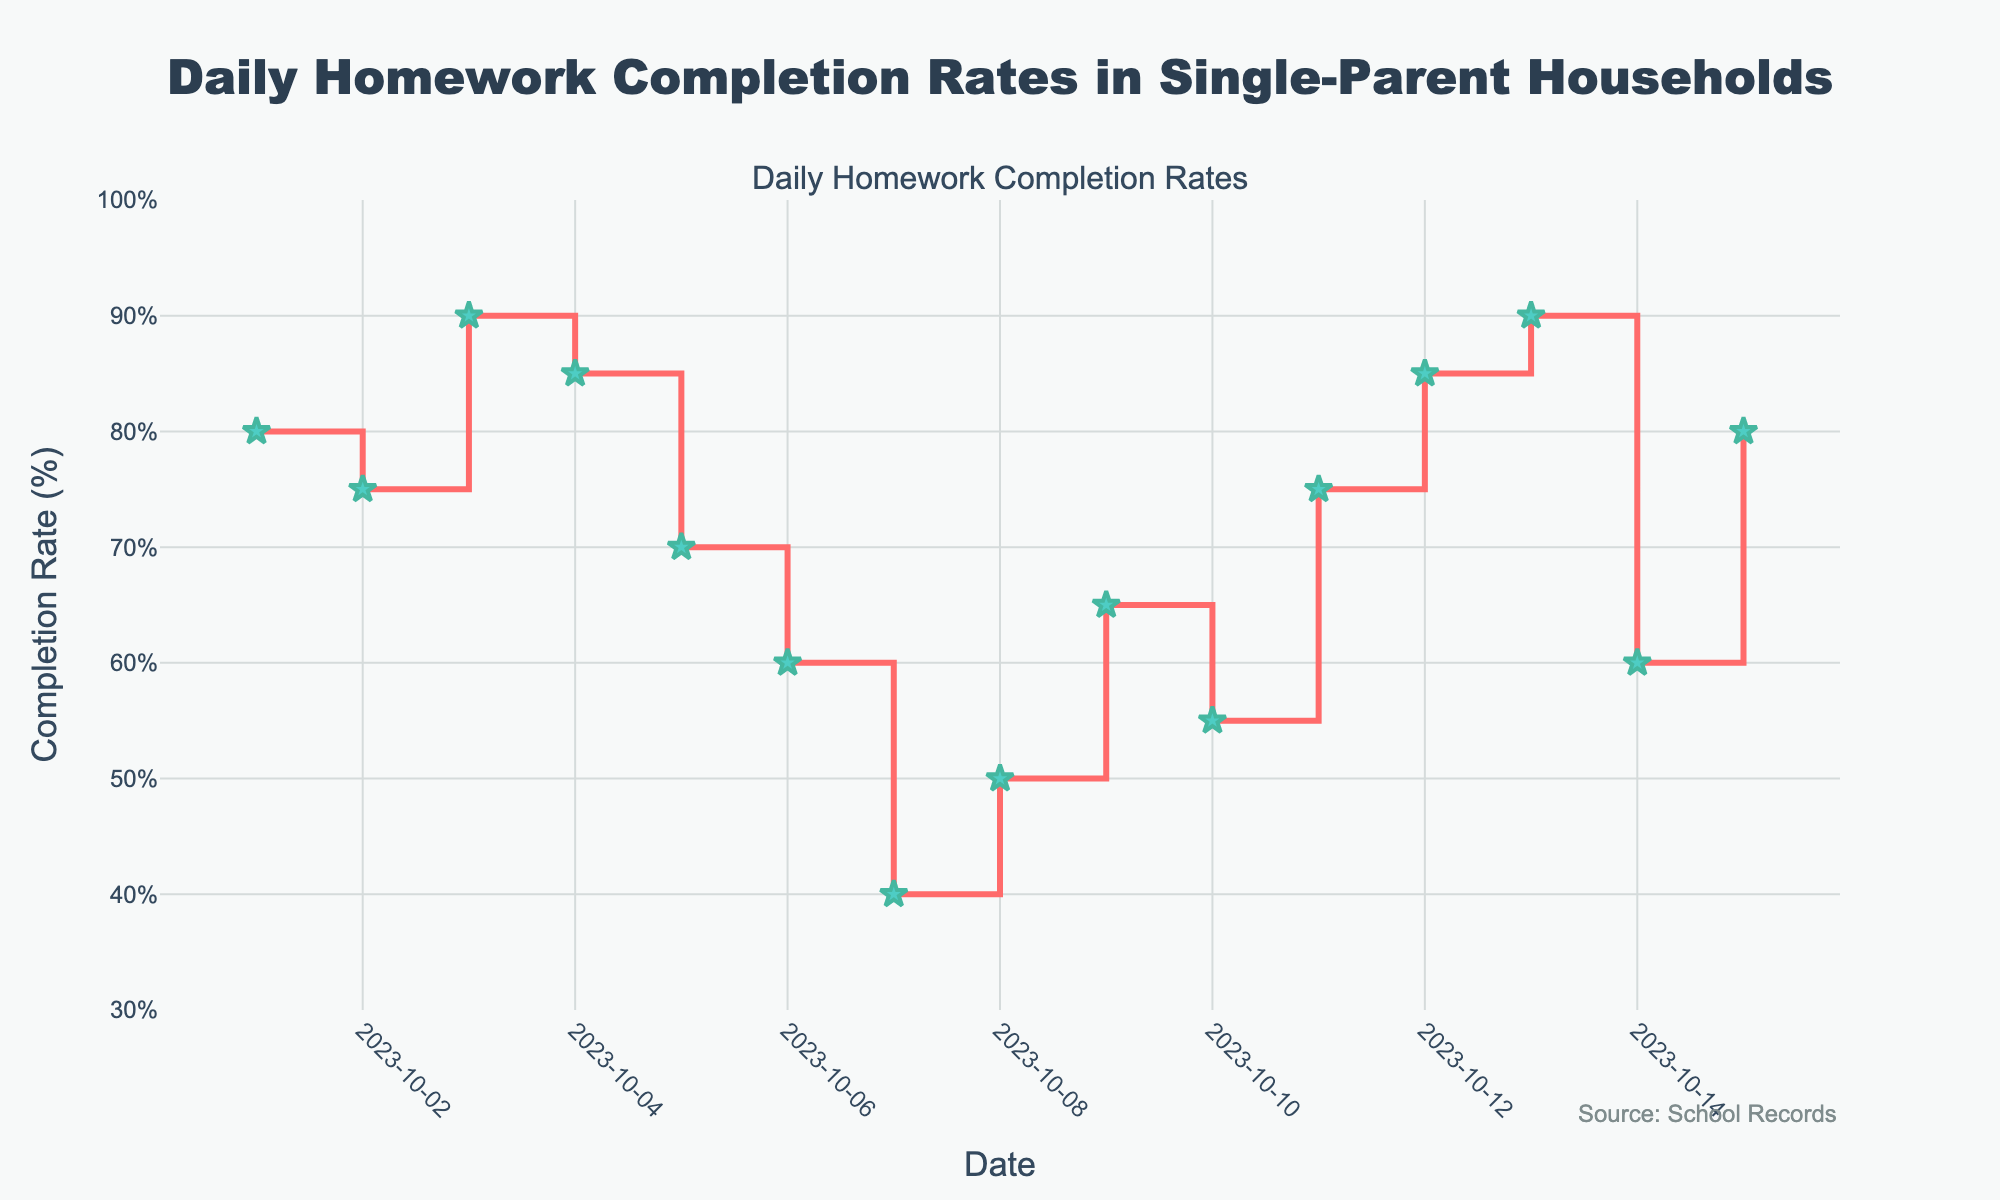What's the title of the figure? The title is prominently displayed at the top of the figure, reading "Daily Homework Completion Rates in Single-Parent Households".
Answer: Daily Homework Completion Rates in Single-Parent Households What are the y-axis units? The y-axis has labels with a '%' symbol, indicating that it measures the completion rate as a percentage.
Answer: Percentage (%) How many days does the data span? The data starts on 2023-10-01 and ends on 2023-10-15, which covers 15 days in total.
Answer: 15 days On which date was the lowest homework completion rate observed? Looking at the stair plot, the lowest point occurs on 2023-10-07 with a completion rate of 40%.
Answer: 2023-10-07 What is the homework completion rate on 2023-10-05? By finding the mark on 2023-10-05, we see the completion rate is 70%.
Answer: 70% How does the completion rate on 2023-10-04 compare to that on 2023-10-11? The completion rate on 2023-10-04 was 85%, while on 2023-10-11 it was 75%, so 2023-10-04 had a higher rate by 10 percentage points.
Answer: 2023-10-04 is 10% higher What is the average homework completion rate over the 15 days? Summing all the percentages and dividing by the number of days: (80+75+90+85+70+60+40+50+65+55+75+85+90+60+80)/15 = 70%.
Answer: 70% How many days had a homework completion rate above 80%? By looking at the data, the days with rates above 80% are 2023-10-03, 2023-10-04, 2023-10-12, and 2023-10-13, which counts to 4 days.
Answer: 4 days What range does the y-axis cover? The y-axis starts at 30% and ends at 100%.
Answer: 30% to 100% How did the homework completion rate change from 2023-10-06 to 2023-10-07? The completion rate dropped from 60% on 2023-10-06 to 40% on 2023-10-07, a decrease of 20 percentage points.
Answer: Decreased by 20% 